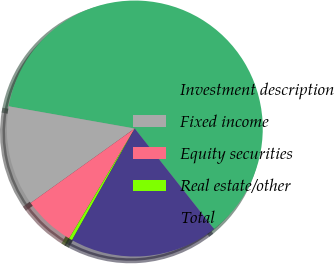Convert chart to OTSL. <chart><loc_0><loc_0><loc_500><loc_500><pie_chart><fcel>Investment description<fcel>Fixed income<fcel>Equity securities<fcel>Real estate/other<fcel>Total<nl><fcel>61.59%<fcel>12.66%<fcel>6.54%<fcel>0.43%<fcel>18.78%<nl></chart> 